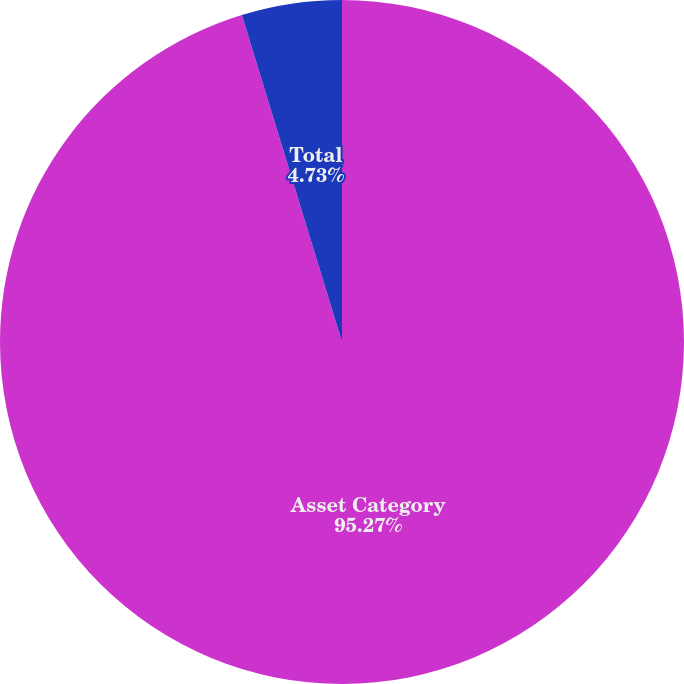<chart> <loc_0><loc_0><loc_500><loc_500><pie_chart><fcel>Asset Category<fcel>Total<nl><fcel>95.27%<fcel>4.73%<nl></chart> 